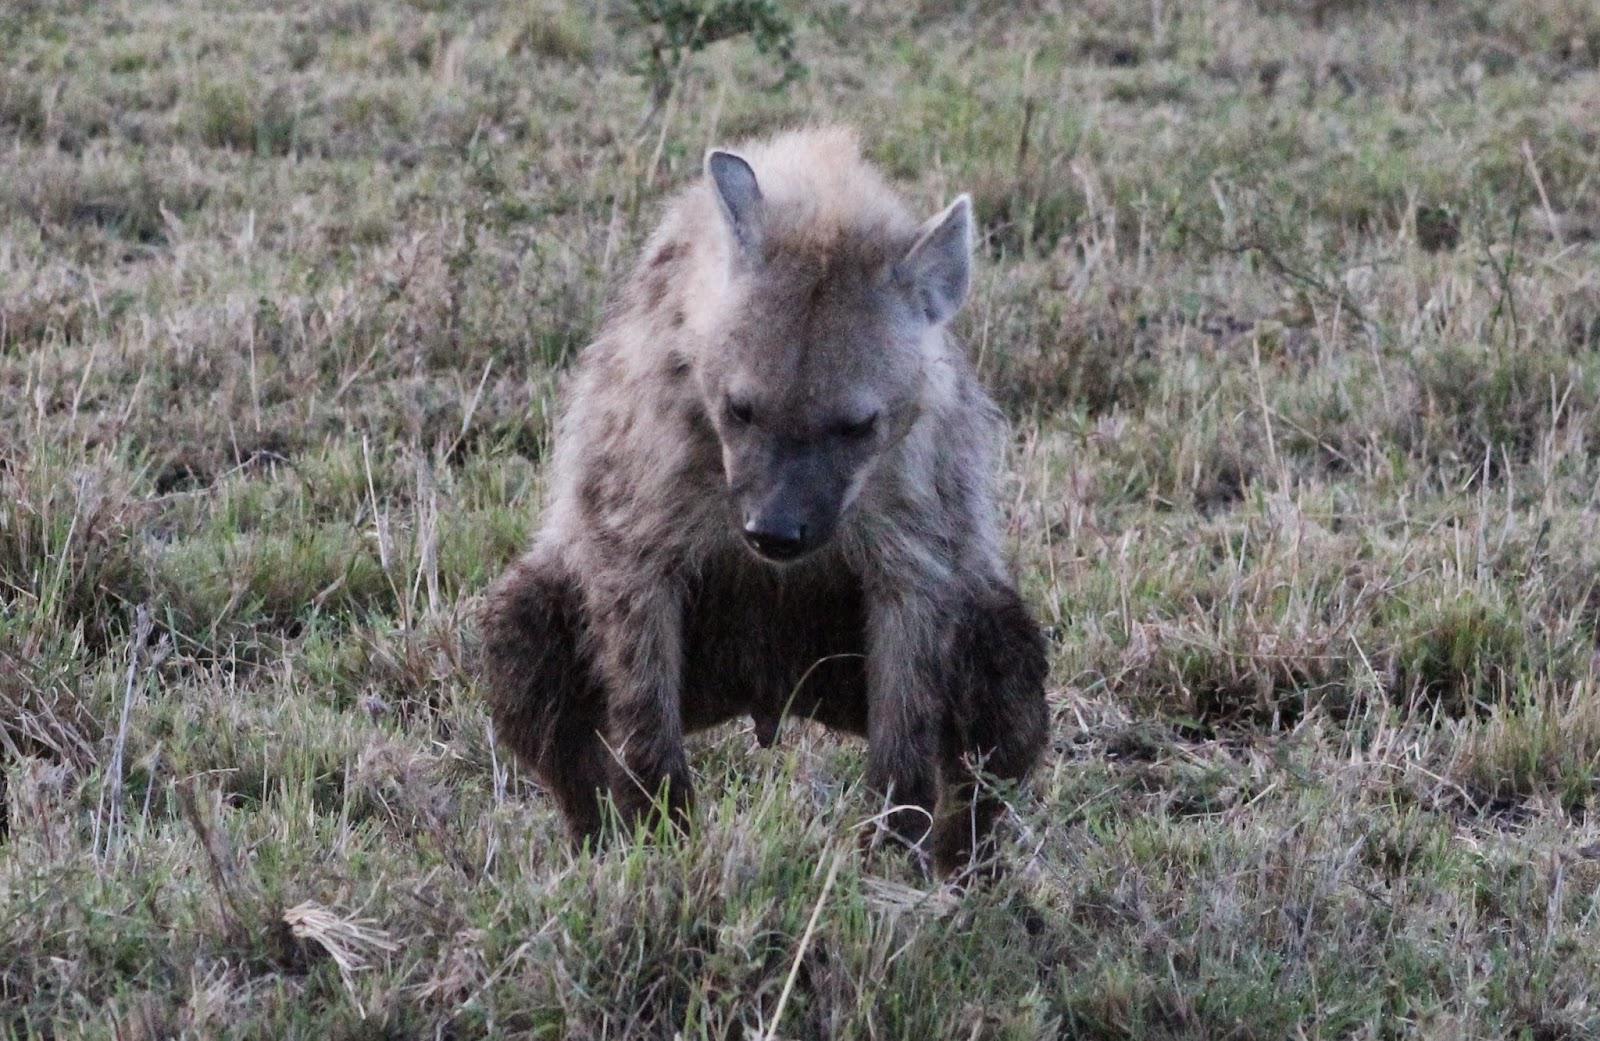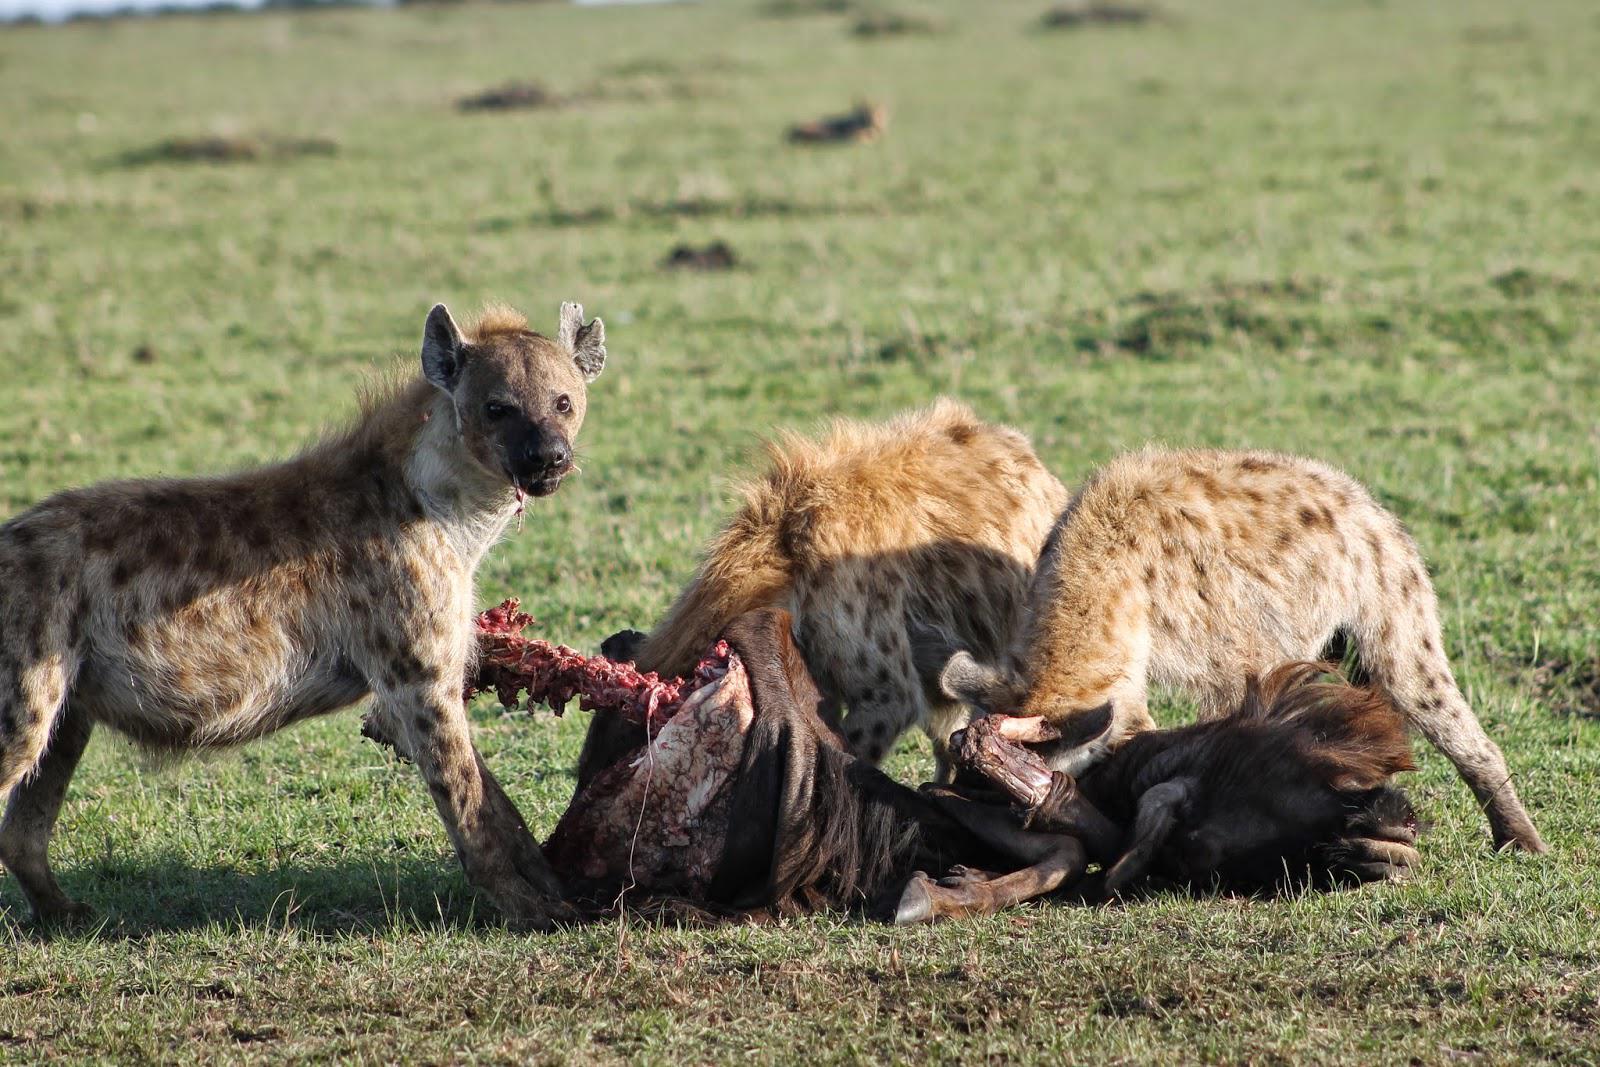The first image is the image on the left, the second image is the image on the right. For the images displayed, is the sentence "The right image contains no more than two hyenas." factually correct? Answer yes or no. No. The first image is the image on the left, the second image is the image on the right. Given the left and right images, does the statement "The left image shows one hyena facing away from the camera and standing next to a downed horned animal that is larger than the hyena." hold true? Answer yes or no. No. 